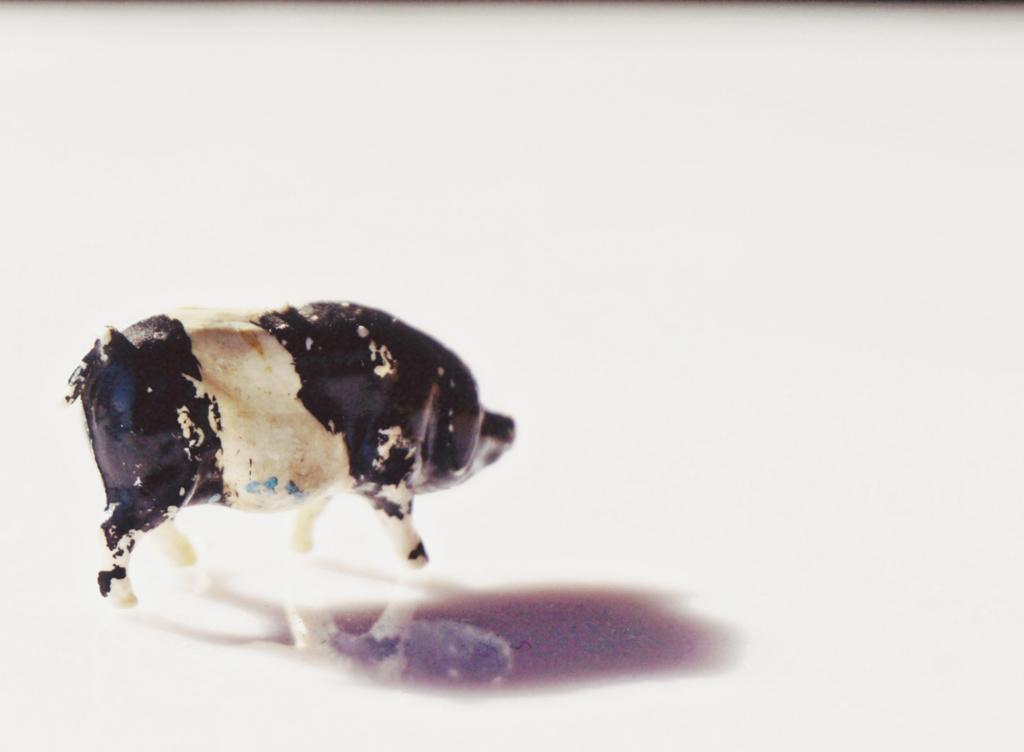How would you summarize this image in a sentence or two? In this image we can see a toy on the white surface. 